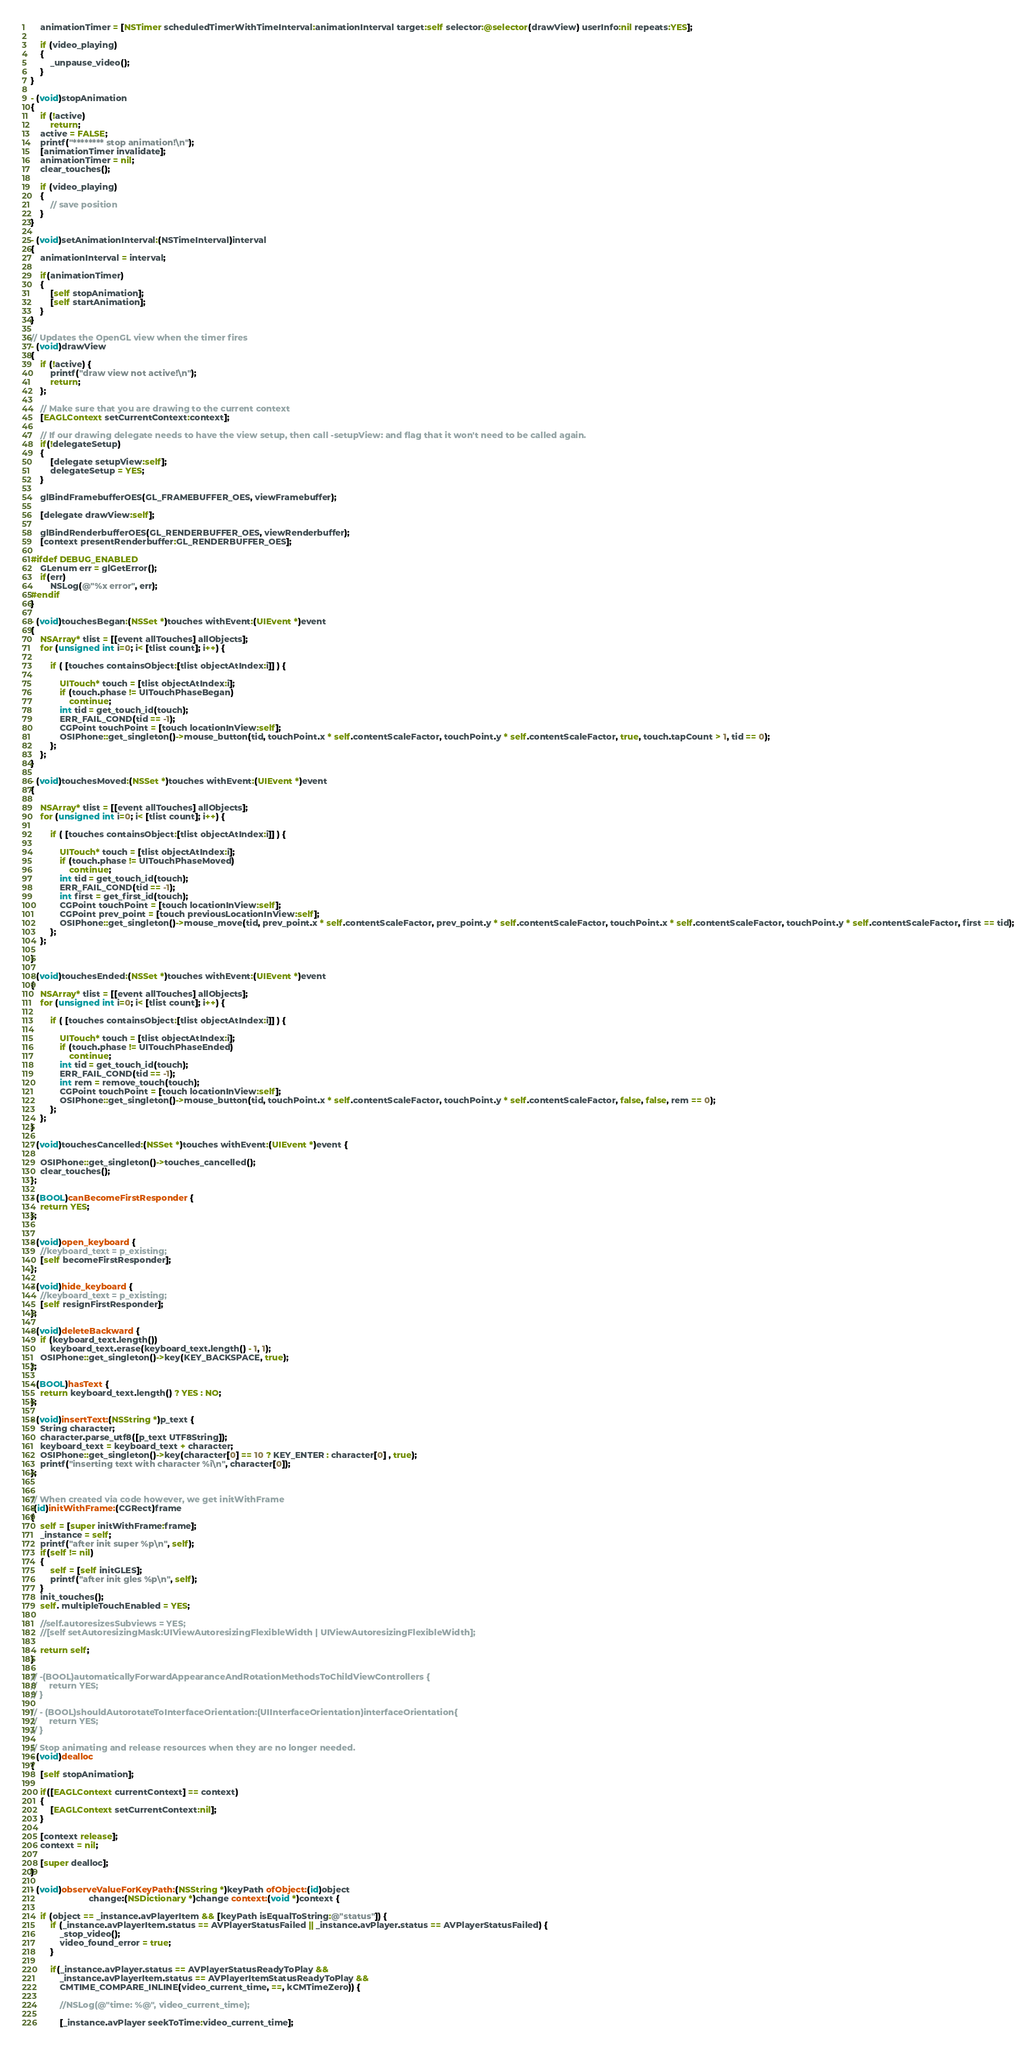<code> <loc_0><loc_0><loc_500><loc_500><_ObjectiveC_>	animationTimer = [NSTimer scheduledTimerWithTimeInterval:animationInterval target:self selector:@selector(drawView) userInfo:nil repeats:YES];

	if (video_playing)
	{
		_unpause_video();
	}
}

- (void)stopAnimation
{
	if (!active)
		return;
	active = FALSE;
	printf("******** stop animation!\n");
	[animationTimer invalidate];
	animationTimer = nil;
	clear_touches();

	if (video_playing)
	{
		// save position
	}
}

- (void)setAnimationInterval:(NSTimeInterval)interval
{
	animationInterval = interval;
	
	if(animationTimer)
	{
		[self stopAnimation];
		[self startAnimation];
	}
}

// Updates the OpenGL view when the timer fires
- (void)drawView
{
	if (!active) {
		printf("draw view not active!\n");
		return;
	};

	// Make sure that you are drawing to the current context
	[EAGLContext setCurrentContext:context];
	
	// If our drawing delegate needs to have the view setup, then call -setupView: and flag that it won't need to be called again.
	if(!delegateSetup)
	{
		[delegate setupView:self];
		delegateSetup = YES;
	}
	
	glBindFramebufferOES(GL_FRAMEBUFFER_OES, viewFramebuffer);

	[delegate drawView:self];
	
	glBindRenderbufferOES(GL_RENDERBUFFER_OES, viewRenderbuffer);
	[context presentRenderbuffer:GL_RENDERBUFFER_OES];
	
#ifdef DEBUG_ENABLED
	GLenum err = glGetError();
	if(err)
		NSLog(@"%x error", err);
#endif
}

- (void)touchesBegan:(NSSet *)touches withEvent:(UIEvent *)event
{
	NSArray* tlist = [[event allTouches] allObjects];
	for (unsigned int i=0; i< [tlist count]; i++) {
		
		if ( [touches containsObject:[tlist objectAtIndex:i]] ) {
			
			UITouch* touch = [tlist objectAtIndex:i];
			if (touch.phase != UITouchPhaseBegan)
				continue;
			int tid = get_touch_id(touch);
			ERR_FAIL_COND(tid == -1);
			CGPoint touchPoint = [touch locationInView:self];
			OSIPhone::get_singleton()->mouse_button(tid, touchPoint.x * self.contentScaleFactor, touchPoint.y * self.contentScaleFactor, true, touch.tapCount > 1, tid == 0);
		};
	};
}

- (void)touchesMoved:(NSSet *)touches withEvent:(UIEvent *)event
{

	NSArray* tlist = [[event allTouches] allObjects];
	for (unsigned int i=0; i< [tlist count]; i++) {
		
		if ( [touches containsObject:[tlist objectAtIndex:i]] ) {
			
			UITouch* touch = [tlist objectAtIndex:i];
			if (touch.phase != UITouchPhaseMoved)
				continue;
			int tid = get_touch_id(touch);
			ERR_FAIL_COND(tid == -1);
			int first = get_first_id(touch);
			CGPoint touchPoint = [touch locationInView:self];
			CGPoint prev_point = [touch previousLocationInView:self];
			OSIPhone::get_singleton()->mouse_move(tid, prev_point.x * self.contentScaleFactor, prev_point.y * self.contentScaleFactor, touchPoint.x * self.contentScaleFactor, touchPoint.y * self.contentScaleFactor, first == tid);
		};
	};

}

- (void)touchesEnded:(NSSet *)touches withEvent:(UIEvent *)event
{
	NSArray* tlist = [[event allTouches] allObjects];
	for (unsigned int i=0; i< [tlist count]; i++) {
		
		if ( [touches containsObject:[tlist objectAtIndex:i]] ) {
			
			UITouch* touch = [tlist objectAtIndex:i];
			if (touch.phase != UITouchPhaseEnded)
				continue;
			int tid = get_touch_id(touch);
			ERR_FAIL_COND(tid == -1);
			int rem = remove_touch(touch);
			CGPoint touchPoint = [touch locationInView:self];
			OSIPhone::get_singleton()->mouse_button(tid, touchPoint.x * self.contentScaleFactor, touchPoint.y * self.contentScaleFactor, false, false, rem == 0);
		};
	};
}

- (void)touchesCancelled:(NSSet *)touches withEvent:(UIEvent *)event {
	
	OSIPhone::get_singleton()->touches_cancelled();
	clear_touches();
};

- (BOOL)canBecomeFirstResponder {
	return YES;
};


- (void)open_keyboard {
	//keyboard_text = p_existing;
	[self becomeFirstResponder];
};

- (void)hide_keyboard {
	//keyboard_text = p_existing;
	[self resignFirstResponder];
};

- (void)deleteBackward {
	if (keyboard_text.length())
		keyboard_text.erase(keyboard_text.length() - 1, 1);
	OSIPhone::get_singleton()->key(KEY_BACKSPACE, true);
};

- (BOOL)hasText {
	return keyboard_text.length() ? YES : NO;
};

- (void)insertText:(NSString *)p_text {
	String character;
	character.parse_utf8([p_text UTF8String]);
	keyboard_text = keyboard_text + character;
	OSIPhone::get_singleton()->key(character[0] == 10 ? KEY_ENTER : character[0] , true);
	printf("inserting text with character %i\n", character[0]);
};


// When created via code however, we get initWithFrame
-(id)initWithFrame:(CGRect)frame
{
	self = [super initWithFrame:frame];
	_instance = self;
	printf("after init super %p\n", self);
	if(self != nil)
	{
		self = [self initGLES];
		printf("after init gles %p\n", self);
	}
	init_touches();
	self. multipleTouchEnabled = YES;

	//self.autoresizesSubviews = YES;
	//[self setAutoresizingMask:UIViewAutoresizingFlexibleWidth | UIViewAutoresizingFlexibleWidth];

	return self;
}

// -(BOOL)automaticallyForwardAppearanceAndRotationMethodsToChildViewControllers {
//     return YES;
// }

// - (BOOL)shouldAutorotateToInterfaceOrientation:(UIInterfaceOrientation)interfaceOrientation{
//     return YES;
// }

// Stop animating and release resources when they are no longer needed.
- (void)dealloc
{
	[self stopAnimation];
	
	if([EAGLContext currentContext] == context)
	{
		[EAGLContext setCurrentContext:nil];
	}
	
	[context release];
	context = nil;

	[super dealloc];
}

- (void)observeValueForKeyPath:(NSString *)keyPath ofObject:(id)object
                        change:(NSDictionary *)change context:(void *)context {

	if (object == _instance.avPlayerItem && [keyPath isEqualToString:@"status"]) {
        if (_instance.avPlayerItem.status == AVPlayerStatusFailed || _instance.avPlayer.status == AVPlayerStatusFailed) {
        	_stop_video();
            video_found_error = true;
        }

        if(_instance.avPlayer.status == AVPlayerStatusReadyToPlay && 
        	_instance.avPlayerItem.status == AVPlayerItemStatusReadyToPlay && 
        	CMTIME_COMPARE_INLINE(video_current_time, ==, kCMTimeZero)) {

        	//NSLog(@"time: %@", video_current_time);

    		[_instance.avPlayer seekToTime:video_current_time];</code> 